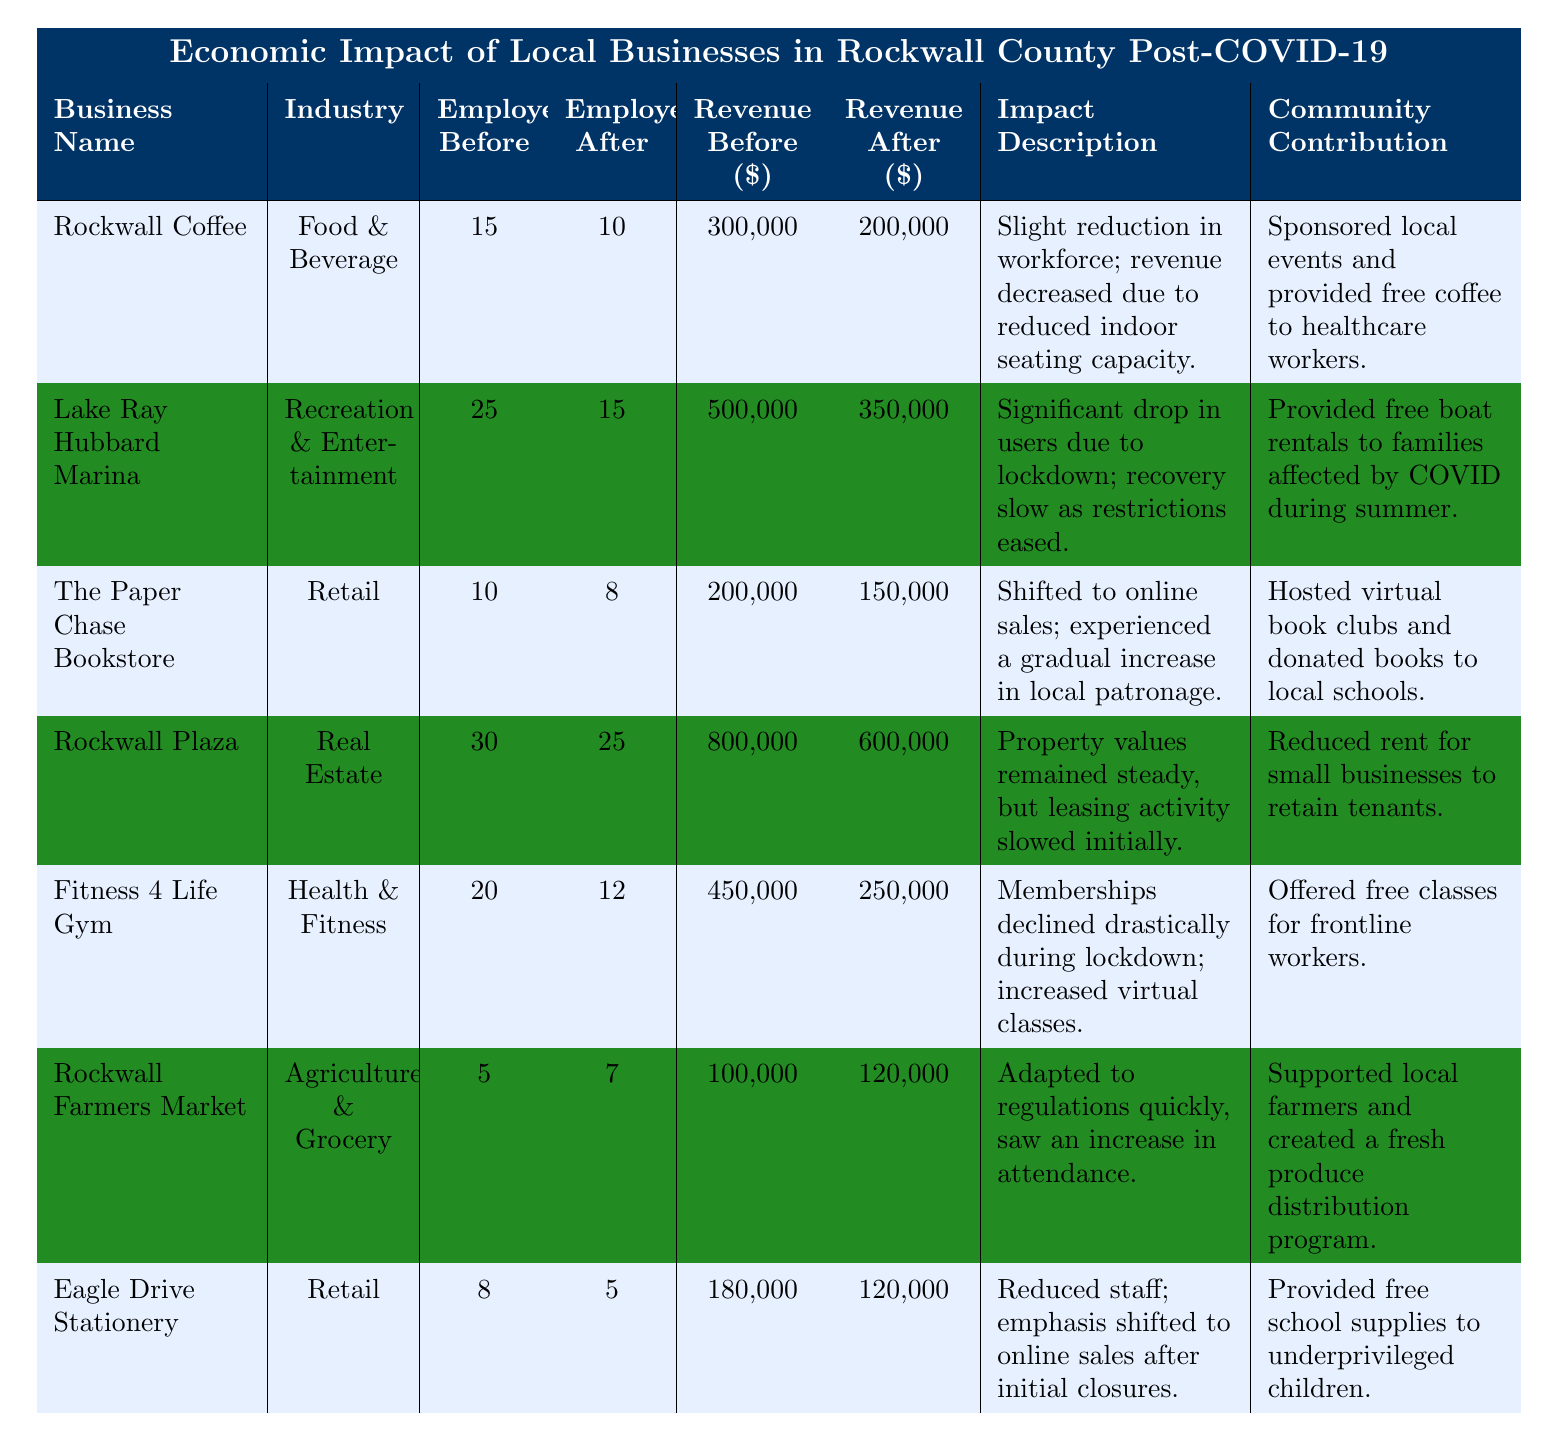What was the annual revenue of Rockwall Coffee before COVID-19? The table lists the annual revenue of Rockwall Coffee before COVID-19 as 300,000.
Answer: 300,000 How many employees did Lake Ray Hubbard Marina have after COVID-19? According to the table, Lake Ray Hubbard Marina had 15 employees after COVID-19.
Answer: 15 What is the total decrease in annual revenue for Fitness 4 Life Gym after COVID-19? The annual revenue before COVID-19 for Fitness 4 Life Gym was 450,000, and after it was 250,000. The decrease is 450,000 - 250,000 = 200,000.
Answer: 200,000 Which business experienced an increase in annual revenue after COVID-19? The table shows that Rockwall Farmers Market had an annual revenue of 100,000 before COVID-19 and 120,000 after, indicating an increase.
Answer: Rockwall Farmers Market Did The Paper Chase Bookstore hire more employees after COVID-19 compared to before? The table indicates that The Paper Chase Bookstore had 10 employees before and 8 after COVID-19, showing a reduction in employees.
Answer: No What is the total number of employees before COVID-19 across all businesses listed? Adding up the employees before COVID-19: 15 + 25 + 10 + 30 + 20 + 5 + 8 = 113 employees in total before COVID-19.
Answer: 113 Which two businesses had the largest revenue decrease after COVID-19? By reviewing the revenue changes, Rockwall Plaza had a decrease of 200,000 (800,000 - 600,000) and Fitness 4 Life Gym had a decrease of 200,000 (450,000 - 250,000), making them the two largest decreases.
Answer: Rockwall Plaza and Fitness 4 Life Gym What percentage of employees did Eagle Drive Stationery lose after COVID-19? Eagle Drive Stationery had 8 employees before and 5 after COVID-19. The percentage lost is calculated as ((8 - 5) / 8) * 100 = 37.5%.
Answer: 37.5% Which business had the highest annual revenue before COVID-19? The table shows that Rockwall Plaza had the highest annual revenue before COVID-19 at 800,000.
Answer: Rockwall Plaza Was the community contribution of Rockwall Farmers Market related to supporting local farmers? Yes, the table notes that Rockwall Farmers Market supported local farmers and created a fresh produce distribution program.
Answer: Yes What was the impact on the workforce size for Rockwall Coffee after COVID-19? The workforce size at Rockwall Coffee decreased from 15 employees to 10 after COVID-19, indicating a reduction.
Answer: Decreased by 5 employees 